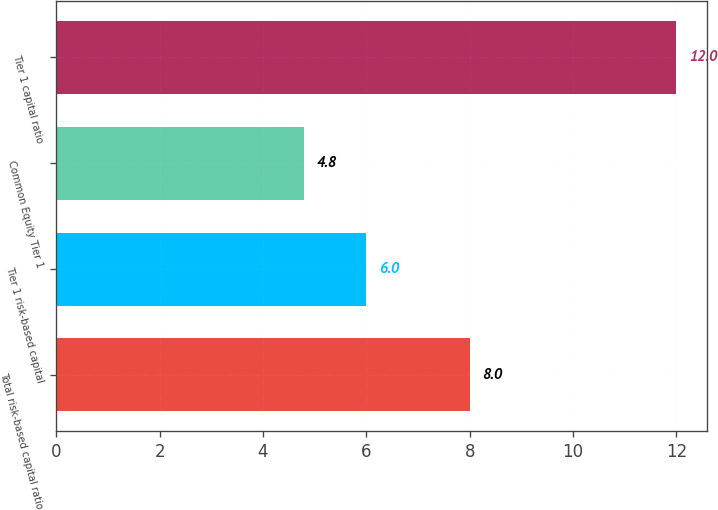Convert chart. <chart><loc_0><loc_0><loc_500><loc_500><bar_chart><fcel>Total risk-based capital ratio<fcel>Tier 1 risk-based capital<fcel>Common Equity Tier 1<fcel>Tier 1 capital ratio<nl><fcel>8<fcel>6<fcel>4.8<fcel>12<nl></chart> 